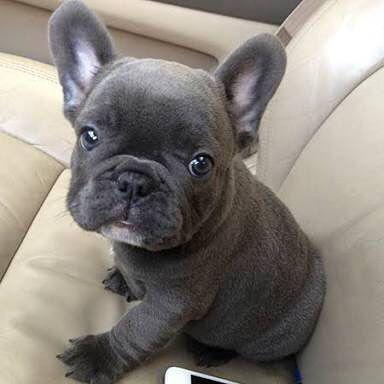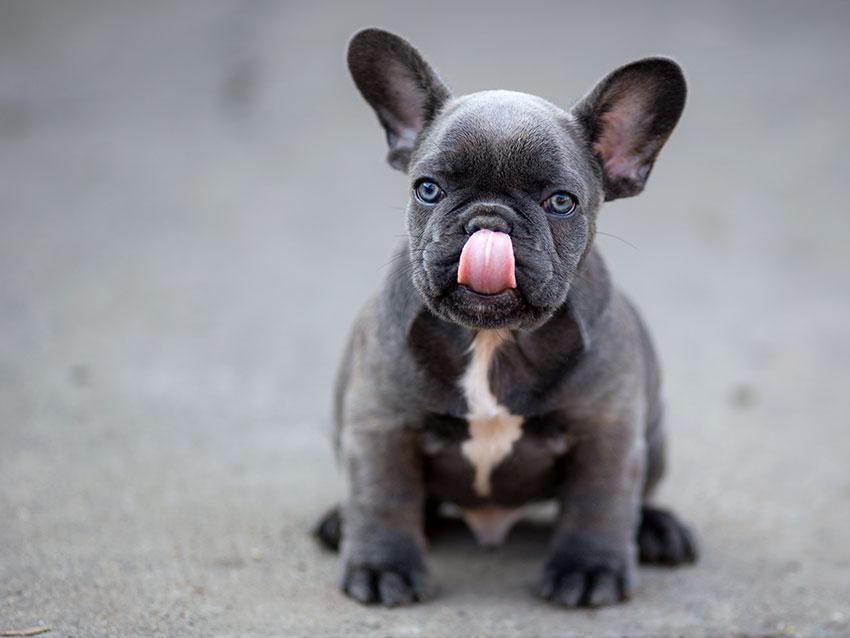The first image is the image on the left, the second image is the image on the right. Evaluate the accuracy of this statement regarding the images: "All of the dogs are charcoal gray, with at most a patch of white on the chest, and all dogs have blue eyes.". Is it true? Answer yes or no. Yes. The first image is the image on the left, the second image is the image on the right. For the images displayed, is the sentence "The dog in the image on the right is outside." factually correct? Answer yes or no. Yes. 